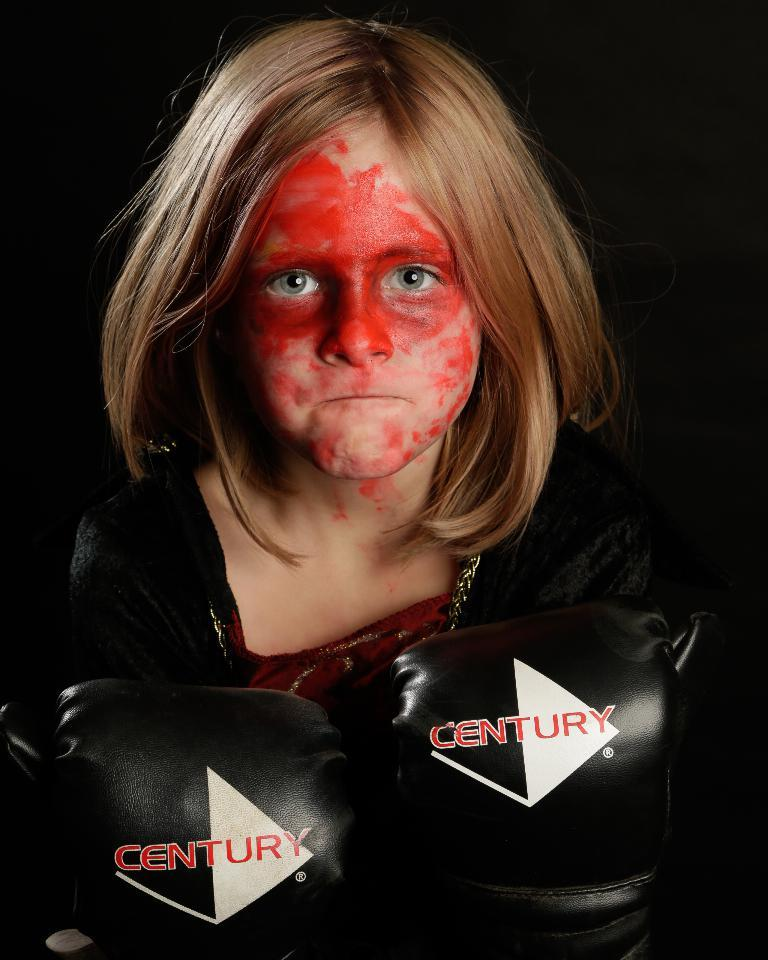Who is the main subject in the image? There is a girl in the image. What is the girl wearing on her hands? The girl is wearing boxing gloves. How many eyes does the girl have on her boxing gloves? The girl does not have eyes on her boxing gloves; they are not a part of the gloves' design. 